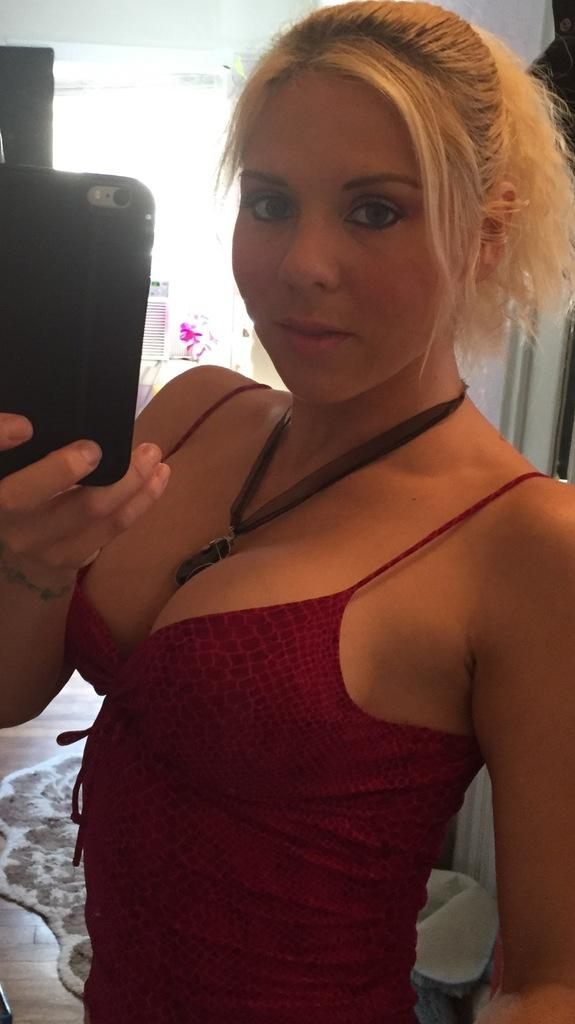Who is present in the image? There is a woman in the image. What is the woman doing in the image? The woman is standing in the image. What object is the woman holding in the image? The woman is holding a mobile phone in the image. What can be seen in the background of the image? There is a curtain and a mat in the background of the image. What type of surface is visible in the image? There is a floor visible in the image. What type of drain can be seen in the image? There is no drain present in the image. What is the woman doing at the top of the image? The image does not have a top or any indication of a specific direction, so it is not possible to determine what the woman is doing at the top. 